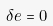<formula> <loc_0><loc_0><loc_500><loc_500>\delta e = 0</formula> 